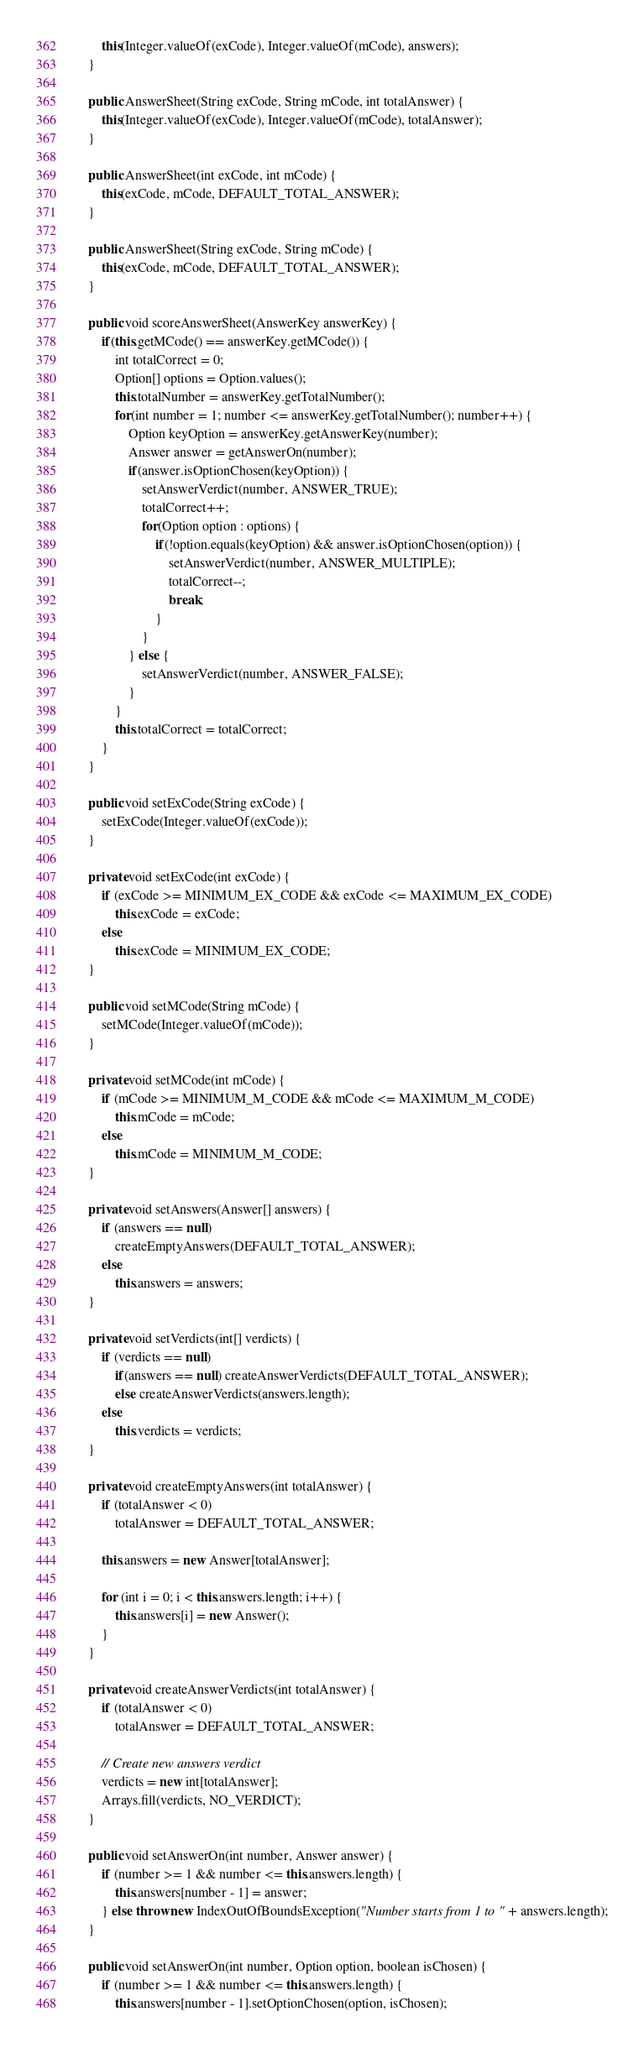Convert code to text. <code><loc_0><loc_0><loc_500><loc_500><_Java_>        this(Integer.valueOf(exCode), Integer.valueOf(mCode), answers);
    }

    public AnswerSheet(String exCode, String mCode, int totalAnswer) {
        this(Integer.valueOf(exCode), Integer.valueOf(mCode), totalAnswer);
    }

    public AnswerSheet(int exCode, int mCode) {
        this(exCode, mCode, DEFAULT_TOTAL_ANSWER);
    }

    public AnswerSheet(String exCode, String mCode) {
        this(exCode, mCode, DEFAULT_TOTAL_ANSWER);
    }

    public void scoreAnswerSheet(AnswerKey answerKey) {
        if(this.getMCode() == answerKey.getMCode()) {
            int totalCorrect = 0;
            Option[] options = Option.values();
            this.totalNumber = answerKey.getTotalNumber();
            for(int number = 1; number <= answerKey.getTotalNumber(); number++) {
                Option keyOption = answerKey.getAnswerKey(number);
                Answer answer = getAnswerOn(number);
                if(answer.isOptionChosen(keyOption)) {
                    setAnswerVerdict(number, ANSWER_TRUE);
                    totalCorrect++;
                    for(Option option : options) {
                        if(!option.equals(keyOption) && answer.isOptionChosen(option)) {
                            setAnswerVerdict(number, ANSWER_MULTIPLE);
                            totalCorrect--;
                            break;
                        }
                    }
                } else {
                    setAnswerVerdict(number, ANSWER_FALSE);
                }
            }
            this.totalCorrect = totalCorrect;
        }
    }

    public void setExCode(String exCode) {
        setExCode(Integer.valueOf(exCode));
    }

    private void setExCode(int exCode) {
        if (exCode >= MINIMUM_EX_CODE && exCode <= MAXIMUM_EX_CODE)
            this.exCode = exCode;
        else
            this.exCode = MINIMUM_EX_CODE;
    }

    public void setMCode(String mCode) {
        setMCode(Integer.valueOf(mCode));
    }

    private void setMCode(int mCode) {
        if (mCode >= MINIMUM_M_CODE && mCode <= MAXIMUM_M_CODE)
            this.mCode = mCode;
        else
            this.mCode = MINIMUM_M_CODE;
    }

    private void setAnswers(Answer[] answers) {
        if (answers == null)
            createEmptyAnswers(DEFAULT_TOTAL_ANSWER);
        else
            this.answers = answers;
    }

    private void setVerdicts(int[] verdicts) {
        if (verdicts == null)
            if(answers == null) createAnswerVerdicts(DEFAULT_TOTAL_ANSWER);
            else createAnswerVerdicts(answers.length);
        else
            this.verdicts = verdicts;
    }

    private void createEmptyAnswers(int totalAnswer) {
        if (totalAnswer < 0)
            totalAnswer = DEFAULT_TOTAL_ANSWER;

        this.answers = new Answer[totalAnswer];

        for (int i = 0; i < this.answers.length; i++) {
            this.answers[i] = new Answer();
        }
    }

    private void createAnswerVerdicts(int totalAnswer) {
        if (totalAnswer < 0)
            totalAnswer = DEFAULT_TOTAL_ANSWER;

        // Create new answers verdict
        verdicts = new int[totalAnswer];
        Arrays.fill(verdicts, NO_VERDICT);
    }

    public void setAnswerOn(int number, Answer answer) {
        if (number >= 1 && number <= this.answers.length) {
            this.answers[number - 1] = answer;
        } else throw new IndexOutOfBoundsException("Number starts from 1 to " + answers.length);
    }

    public void setAnswerOn(int number, Option option, boolean isChosen) {
        if (number >= 1 && number <= this.answers.length) {
            this.answers[number - 1].setOptionChosen(option, isChosen);</code> 